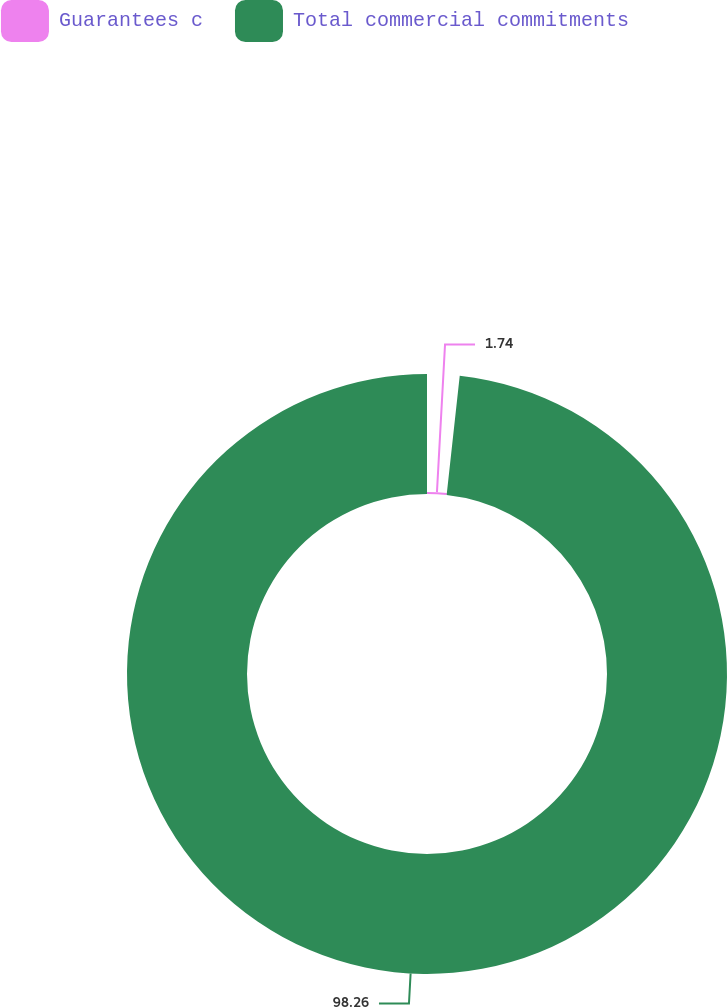Convert chart to OTSL. <chart><loc_0><loc_0><loc_500><loc_500><pie_chart><fcel>Guarantees c<fcel>Total commercial commitments<nl><fcel>1.74%<fcel>98.26%<nl></chart> 